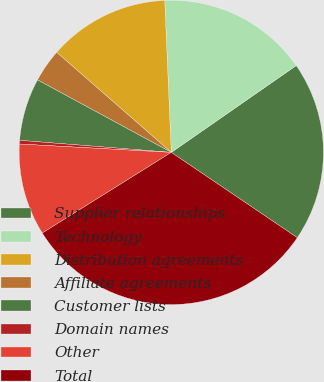Convert chart. <chart><loc_0><loc_0><loc_500><loc_500><pie_chart><fcel>Supplier relationships<fcel>Technology<fcel>Distribution agreements<fcel>Affiliate agreements<fcel>Customer lists<fcel>Domain names<fcel>Other<fcel>Total<nl><fcel>19.14%<fcel>16.02%<fcel>12.89%<fcel>3.52%<fcel>6.64%<fcel>0.39%<fcel>9.77%<fcel>31.64%<nl></chart> 